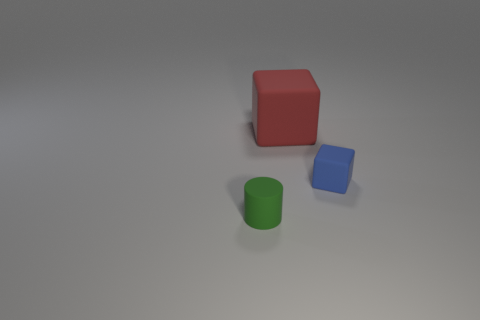Is there anything else that is the same material as the big red cube?
Keep it short and to the point. Yes. What number of things are either small rubber things on the right side of the tiny green cylinder or tiny blocks?
Your answer should be compact. 1. There is a thing that is left of the cube to the left of the tiny blue object; are there any small blocks that are left of it?
Give a very brief answer. No. How many big things are there?
Your response must be concise. 1. What number of things are small rubber things on the right side of the rubber cylinder or tiny matte objects to the left of the big red rubber cube?
Your response must be concise. 2. There is a cube behind the blue cube; is it the same size as the green thing?
Offer a very short reply. No. What size is the other matte thing that is the same shape as the big thing?
Make the answer very short. Small. There is a cube that is the same size as the cylinder; what is it made of?
Make the answer very short. Rubber. What material is the tiny blue thing that is the same shape as the red object?
Ensure brevity in your answer.  Rubber. What number of other things are there of the same size as the blue matte object?
Offer a very short reply. 1. 